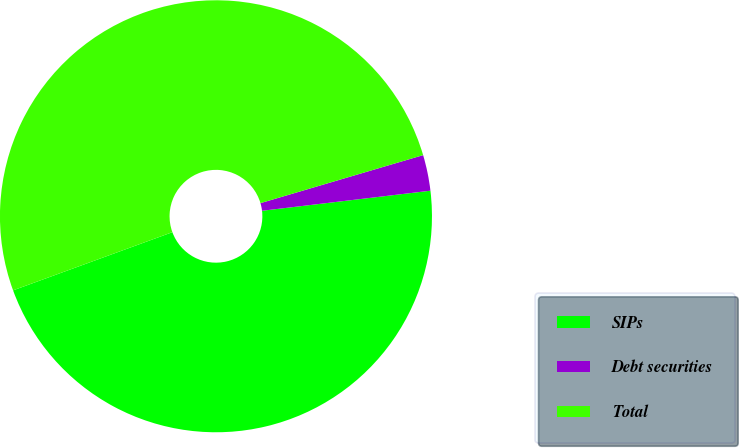<chart> <loc_0><loc_0><loc_500><loc_500><pie_chart><fcel>SIPs<fcel>Debt securities<fcel>Total<nl><fcel>46.32%<fcel>2.68%<fcel>51.01%<nl></chart> 